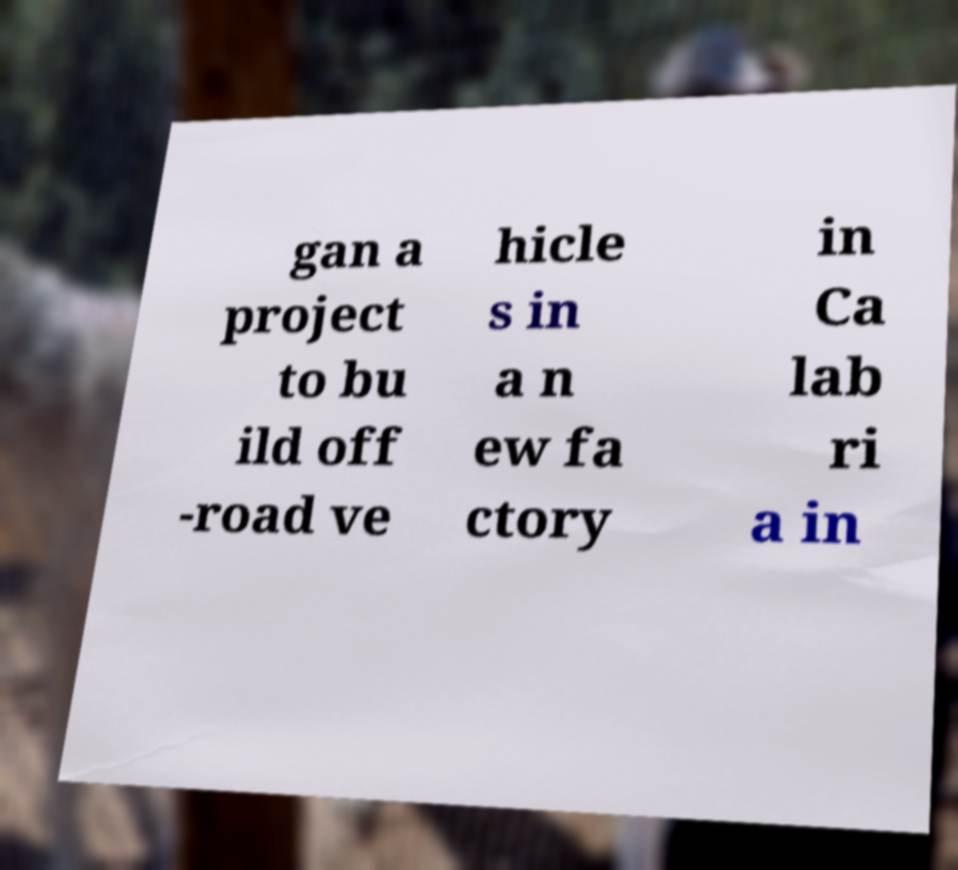Can you read and provide the text displayed in the image?This photo seems to have some interesting text. Can you extract and type it out for me? gan a project to bu ild off -road ve hicle s in a n ew fa ctory in Ca lab ri a in 